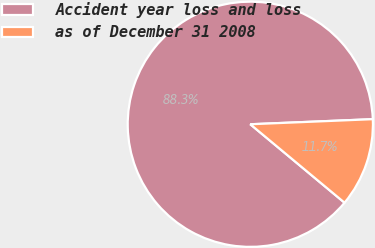Convert chart. <chart><loc_0><loc_0><loc_500><loc_500><pie_chart><fcel>Accident year loss and loss<fcel>as of December 31 2008<nl><fcel>88.29%<fcel>11.71%<nl></chart> 